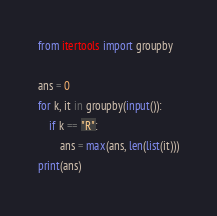<code> <loc_0><loc_0><loc_500><loc_500><_Python_>from itertools import groupby

ans = 0
for k, it in groupby(input()):
    if k == "R":
        ans = max(ans, len(list(it)))
print(ans)
</code> 